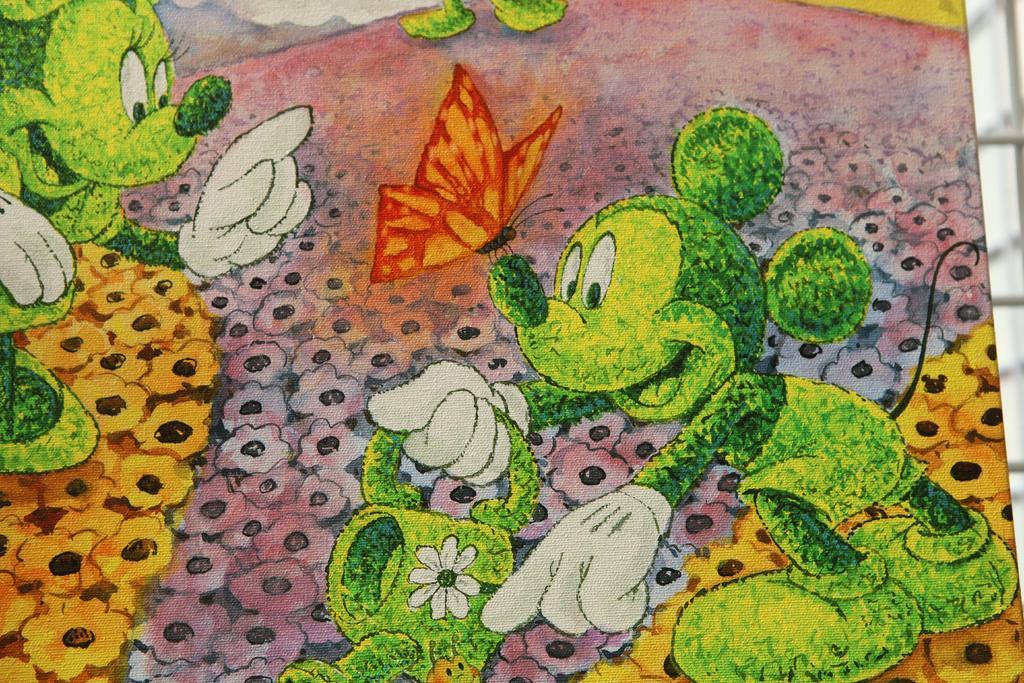Could you give a brief overview of what you see in this image? In this image I can see the drawing of two cartoons which are in green color. I can see one cartoon is holding the jug and there is a butterfly on the cartoon. I can see the drawing is colorful. 